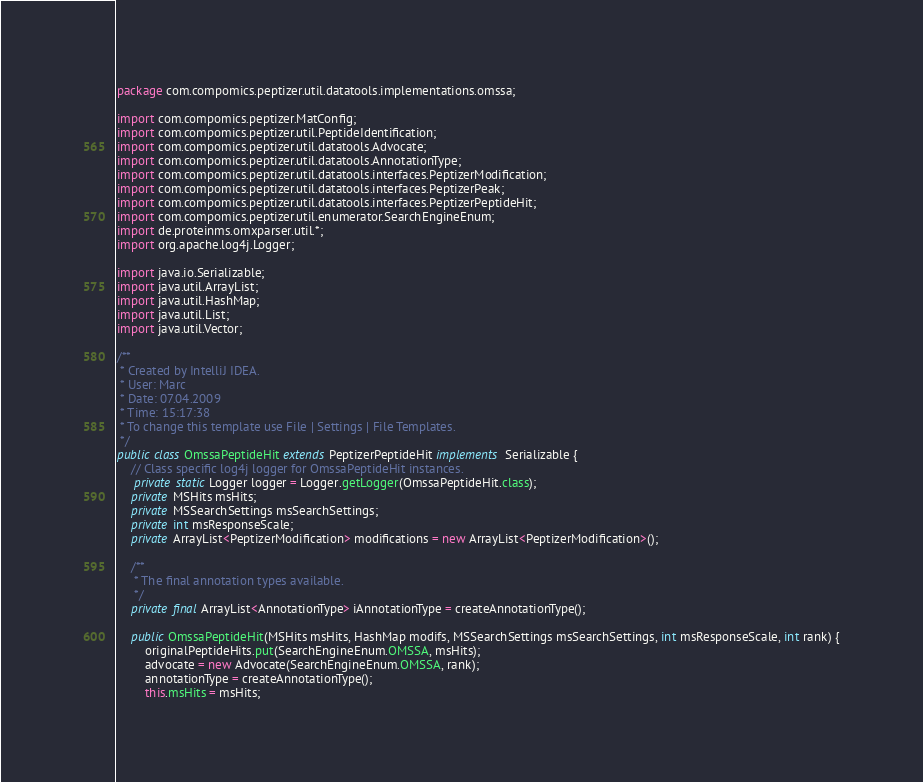Convert code to text. <code><loc_0><loc_0><loc_500><loc_500><_Java_>package com.compomics.peptizer.util.datatools.implementations.omssa;

import com.compomics.peptizer.MatConfig;
import com.compomics.peptizer.util.PeptideIdentification;
import com.compomics.peptizer.util.datatools.Advocate;
import com.compomics.peptizer.util.datatools.AnnotationType;
import com.compomics.peptizer.util.datatools.interfaces.PeptizerModification;
import com.compomics.peptizer.util.datatools.interfaces.PeptizerPeak;
import com.compomics.peptizer.util.datatools.interfaces.PeptizerPeptideHit;
import com.compomics.peptizer.util.enumerator.SearchEngineEnum;
import de.proteinms.omxparser.util.*;
import org.apache.log4j.Logger;

import java.io.Serializable;
import java.util.ArrayList;
import java.util.HashMap;
import java.util.List;
import java.util.Vector;

/**
 * Created by IntelliJ IDEA.
 * User: Marc
 * Date: 07.04.2009
 * Time: 15:17:38
 * To change this template use File | Settings | File Templates.
 */
public class OmssaPeptideHit extends PeptizerPeptideHit implements Serializable {
	// Class specific log4j logger for OmssaPeptideHit instances.
	 private static Logger logger = Logger.getLogger(OmssaPeptideHit.class);
    private MSHits msHits;
    private MSSearchSettings msSearchSettings;
    private int msResponseScale;
    private ArrayList<PeptizerModification> modifications = new ArrayList<PeptizerModification>();

    /**
     * The final annotation types available.
     */
    private final ArrayList<AnnotationType> iAnnotationType = createAnnotationType();

    public OmssaPeptideHit(MSHits msHits, HashMap modifs, MSSearchSettings msSearchSettings, int msResponseScale, int rank) {
        originalPeptideHits.put(SearchEngineEnum.OMSSA, msHits);
        advocate = new Advocate(SearchEngineEnum.OMSSA, rank);
        annotationType = createAnnotationType();
        this.msHits = msHits;</code> 